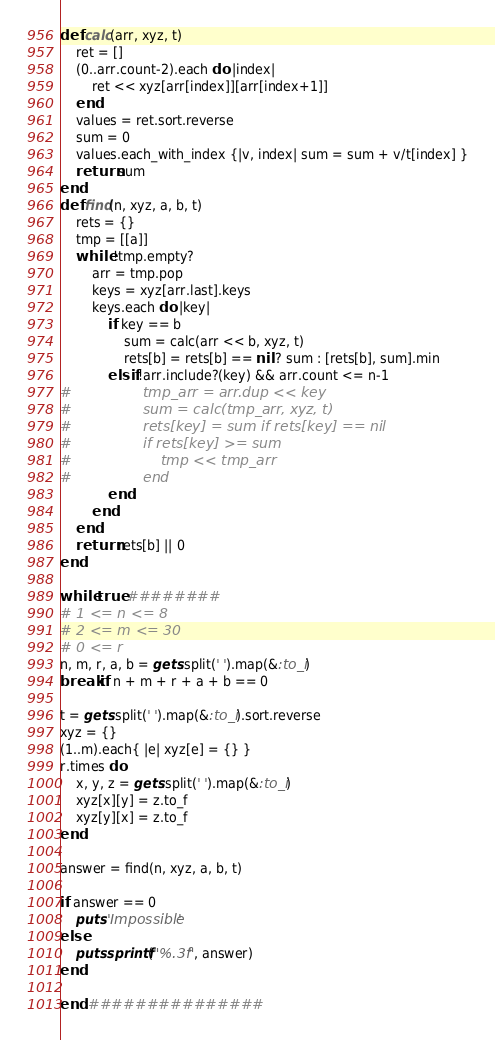<code> <loc_0><loc_0><loc_500><loc_500><_Ruby_>def calc(arr, xyz, t)
    ret = []
    (0..arr.count-2).each do |index|
        ret << xyz[arr[index]][arr[index+1]]
    end
    values = ret.sort.reverse
    sum = 0
    values.each_with_index {|v, index| sum = sum + v/t[index] }
    return sum
end
def find(n, xyz, a, b, t)
    rets = {}
    tmp = [[a]]
    while !tmp.empty?
        arr = tmp.pop
        keys = xyz[arr.last].keys
        keys.each do |key|
            if key == b
                sum = calc(arr << b, xyz, t)
                rets[b] = rets[b] == nil ? sum : [rets[b], sum].min
            elsif !arr.include?(key) && arr.count <= n-1
#                tmp_arr = arr.dup << key
#                sum = calc(tmp_arr, xyz, t)
#                rets[key] = sum if rets[key] == nil
#                if rets[key] >= sum
#                    tmp << tmp_arr
#                end
            end
        end
    end
    return rets[b] || 0
end

while true ########
# 1 <= n <= 8
# 2 <= m <= 30
# 0 <= r
n, m, r, a, b = gets.split(' ').map(&:to_i)
break if n + m + r + a + b == 0

t = gets.split(' ').map(&:to_i).sort.reverse
xyz = {}
(1..m).each{ |e| xyz[e] = {} }
r.times do
    x, y, z = gets.split(' ').map(&:to_i)
    xyz[x][y] = z.to_f
    xyz[y][x] = z.to_f
end

answer = find(n, xyz, a, b, t)

if answer == 0
    puts 'Impossible'
else
    puts sprintf("%.3f", answer)
end

end ###############
</code> 